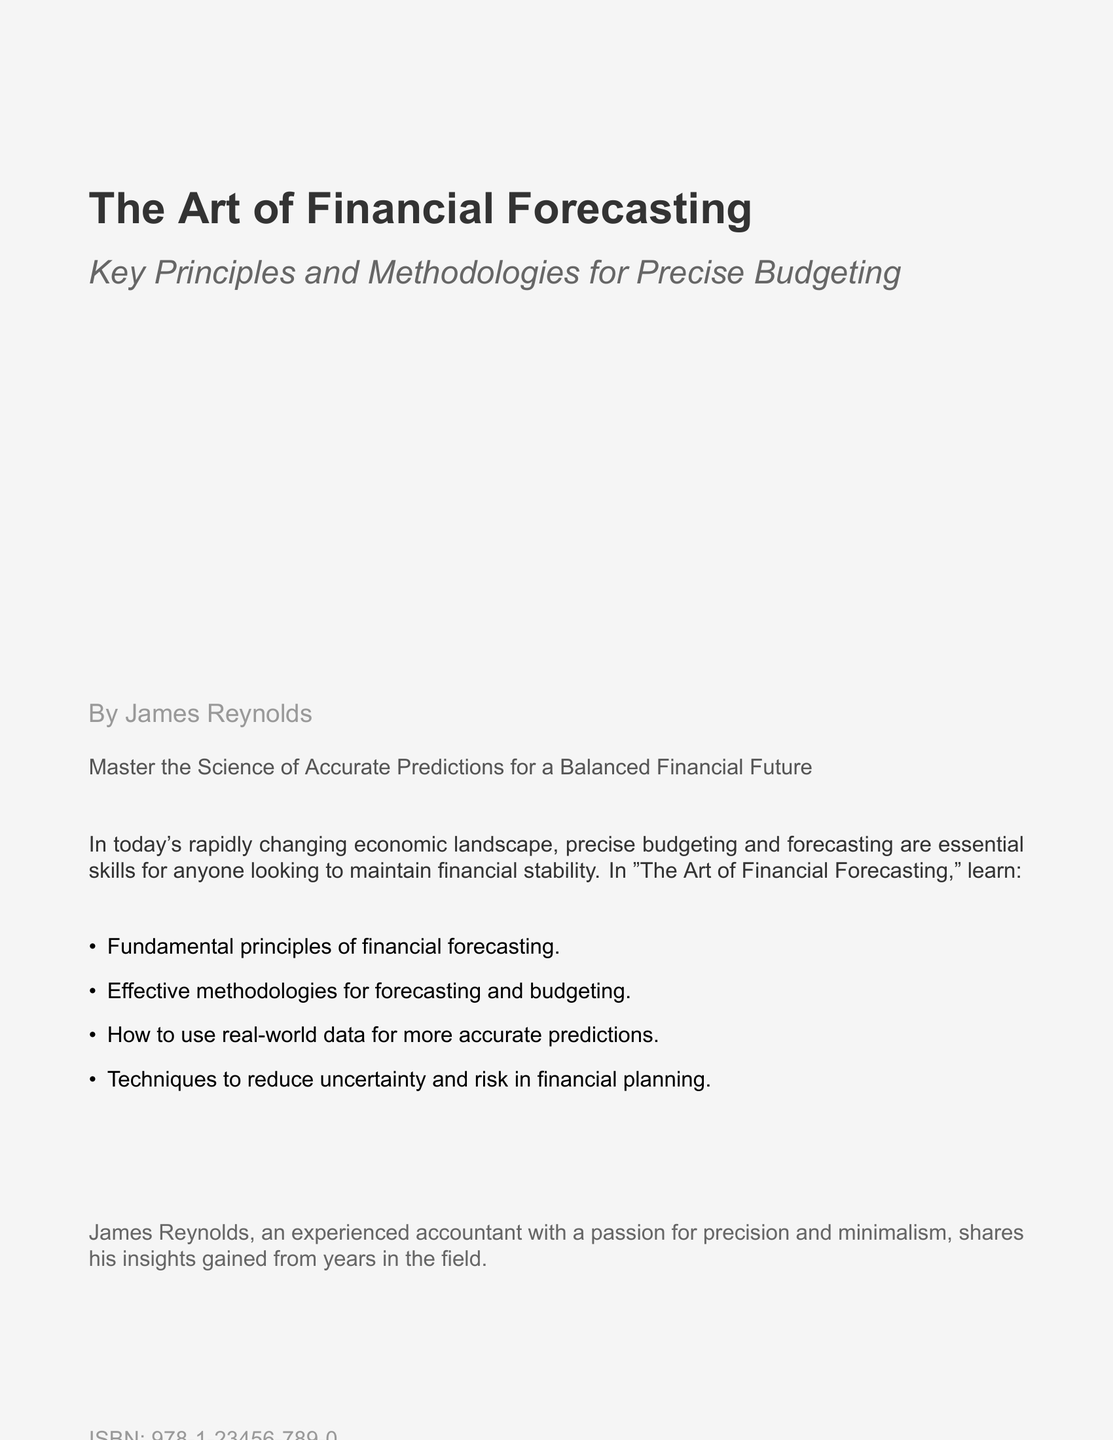What is the title of the book? The title appears prominently on the cover and is "The Art of Financial Forecasting."
Answer: The Art of Financial Forecasting Who is the author of the book? The author's name is stated at the bottom of the cover.
Answer: James Reynolds What is the main focus of this book? The subtitle provides insight into the book's focus on budgeting and forecasting methodologies.
Answer: Precise Budgeting What is the ISBN of the book? The ISBN number can be found on the back cover content section of the document.
Answer: 978-1-23456-789-0 What color is used for the background of the document? The document specifies a background color with the code F5F5F5.
Answer: F5F5F5 What is described as essential skills in the text? The text mentions the importance of certain skills in the context of financial stability.
Answer: Precise budgeting and forecasting How many key points are listed in the book description? Counting the items in the list of key points reveals the quantity.
Answer: Four What kind of methodologies does the book discuss? The subtitle mentions effective methodologies relevant to the book's main topic.
Answer: Forecasting and budgeting 